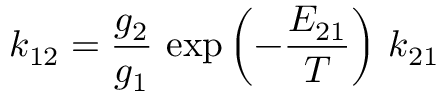<formula> <loc_0><loc_0><loc_500><loc_500>k _ { 1 2 } = \frac { g _ { 2 } } { g _ { 1 } } \, \exp \left ( - \frac { E _ { 2 1 } } { T } \right ) \, k _ { 2 1 }</formula> 